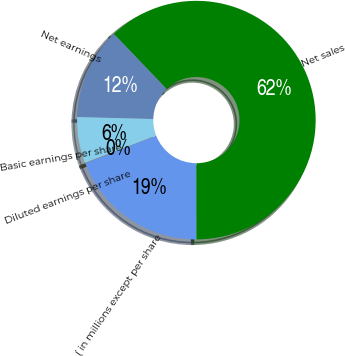Convert chart. <chart><loc_0><loc_0><loc_500><loc_500><pie_chart><fcel>( in millions except per share<fcel>Net sales<fcel>Net earnings<fcel>Basic earnings per share<fcel>Diluted earnings per share<nl><fcel>19.17%<fcel>62.12%<fcel>12.44%<fcel>6.23%<fcel>0.03%<nl></chart> 